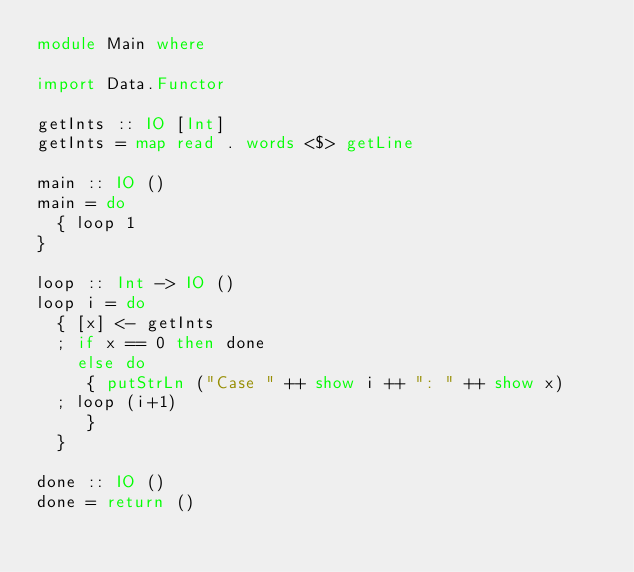Convert code to text. <code><loc_0><loc_0><loc_500><loc_500><_Haskell_>module Main where

import Data.Functor

getInts :: IO [Int]
getInts = map read . words <$> getLine

main :: IO ()
main = do
  { loop 1
}

loop :: Int -> IO ()
loop i = do
  { [x] <- getInts
  ; if x == 0 then done
    else do
     { putStrLn ("Case " ++ show i ++ ": " ++ show x)
  ; loop (i+1)
     }
  }

done :: IO ()
done = return ()</code> 